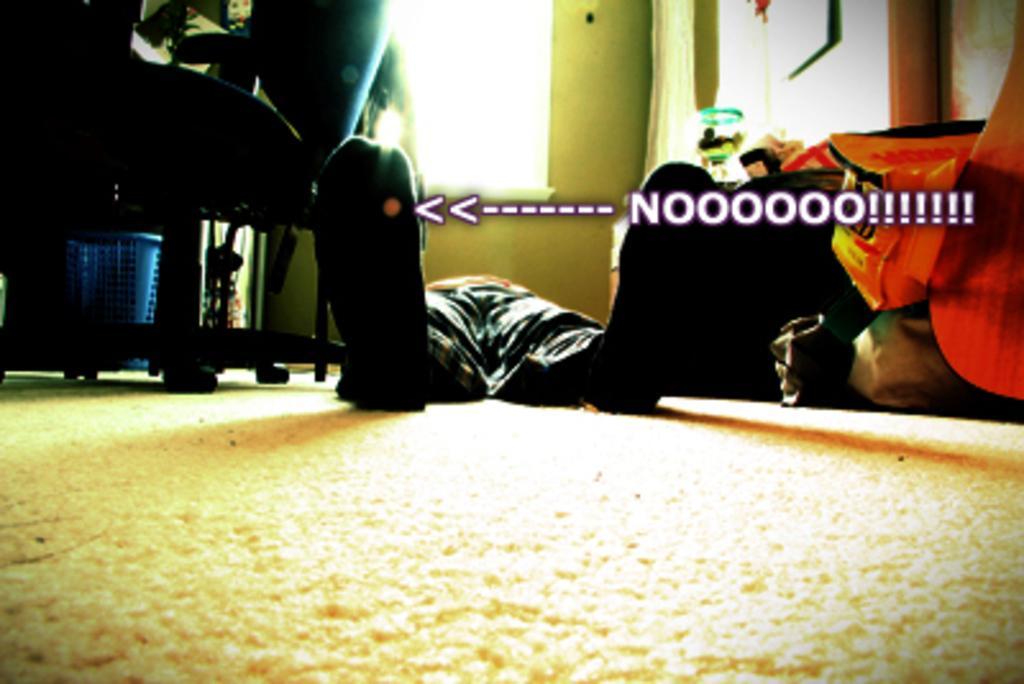Can you describe this image briefly? In this image I can see the person lying on the floor. To the left I can see the chair and the blue color basket. To the right I can see some objects. In the background I can see the window blind and the wall in the back. 